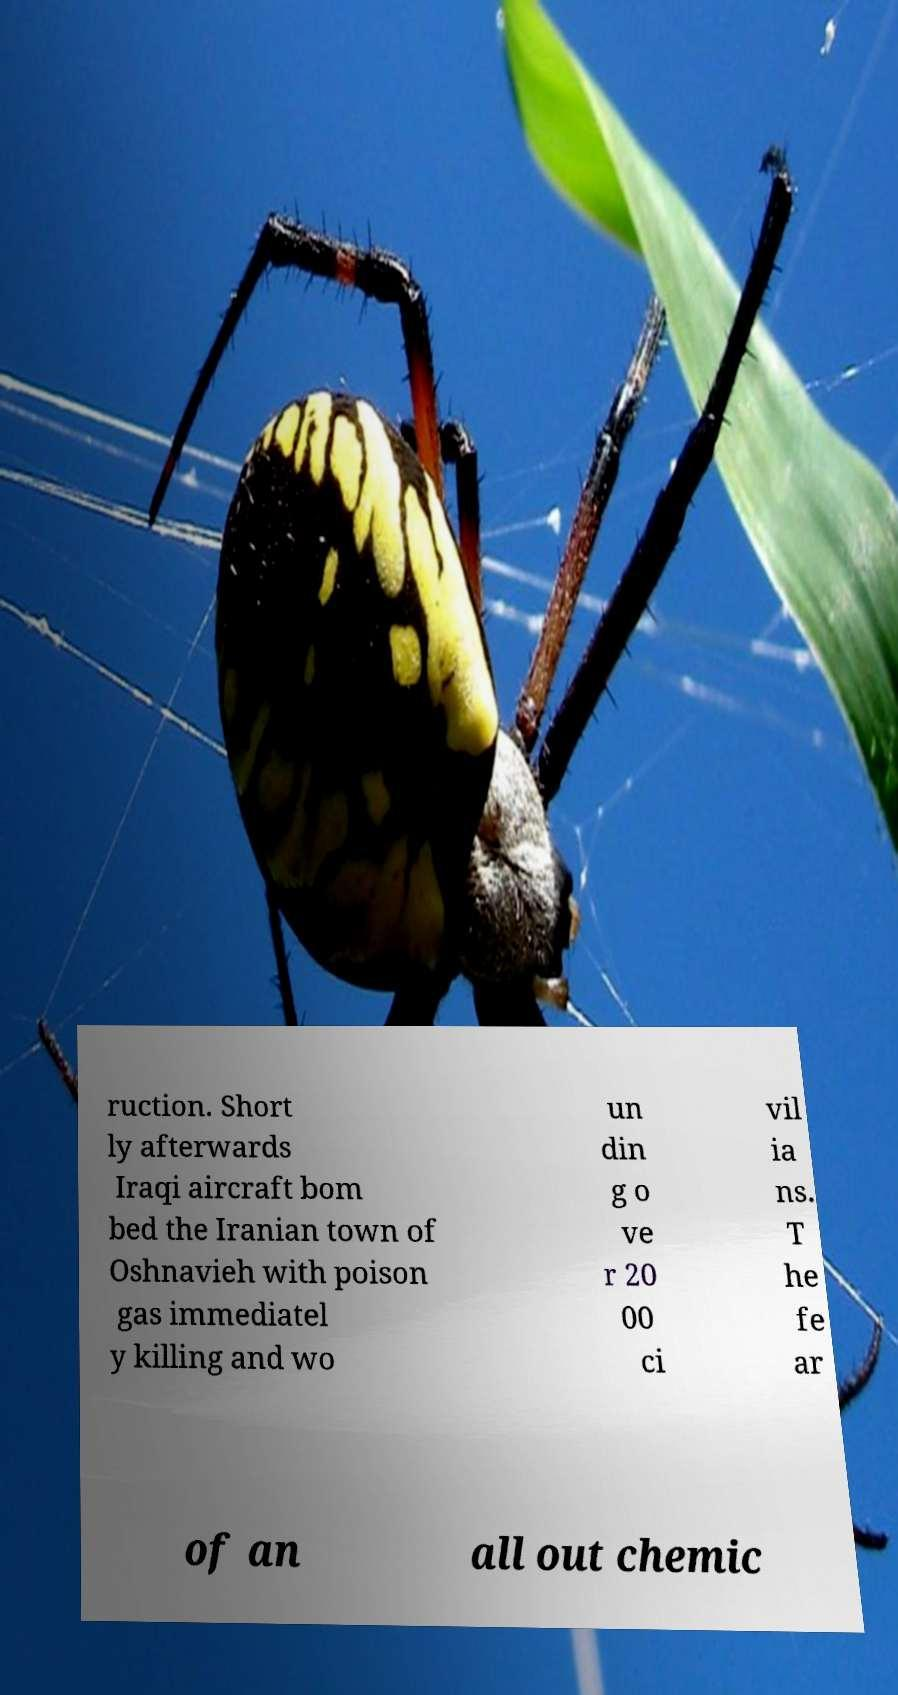Please identify and transcribe the text found in this image. ruction. Short ly afterwards Iraqi aircraft bom bed the Iranian town of Oshnavieh with poison gas immediatel y killing and wo un din g o ve r 20 00 ci vil ia ns. T he fe ar of an all out chemic 